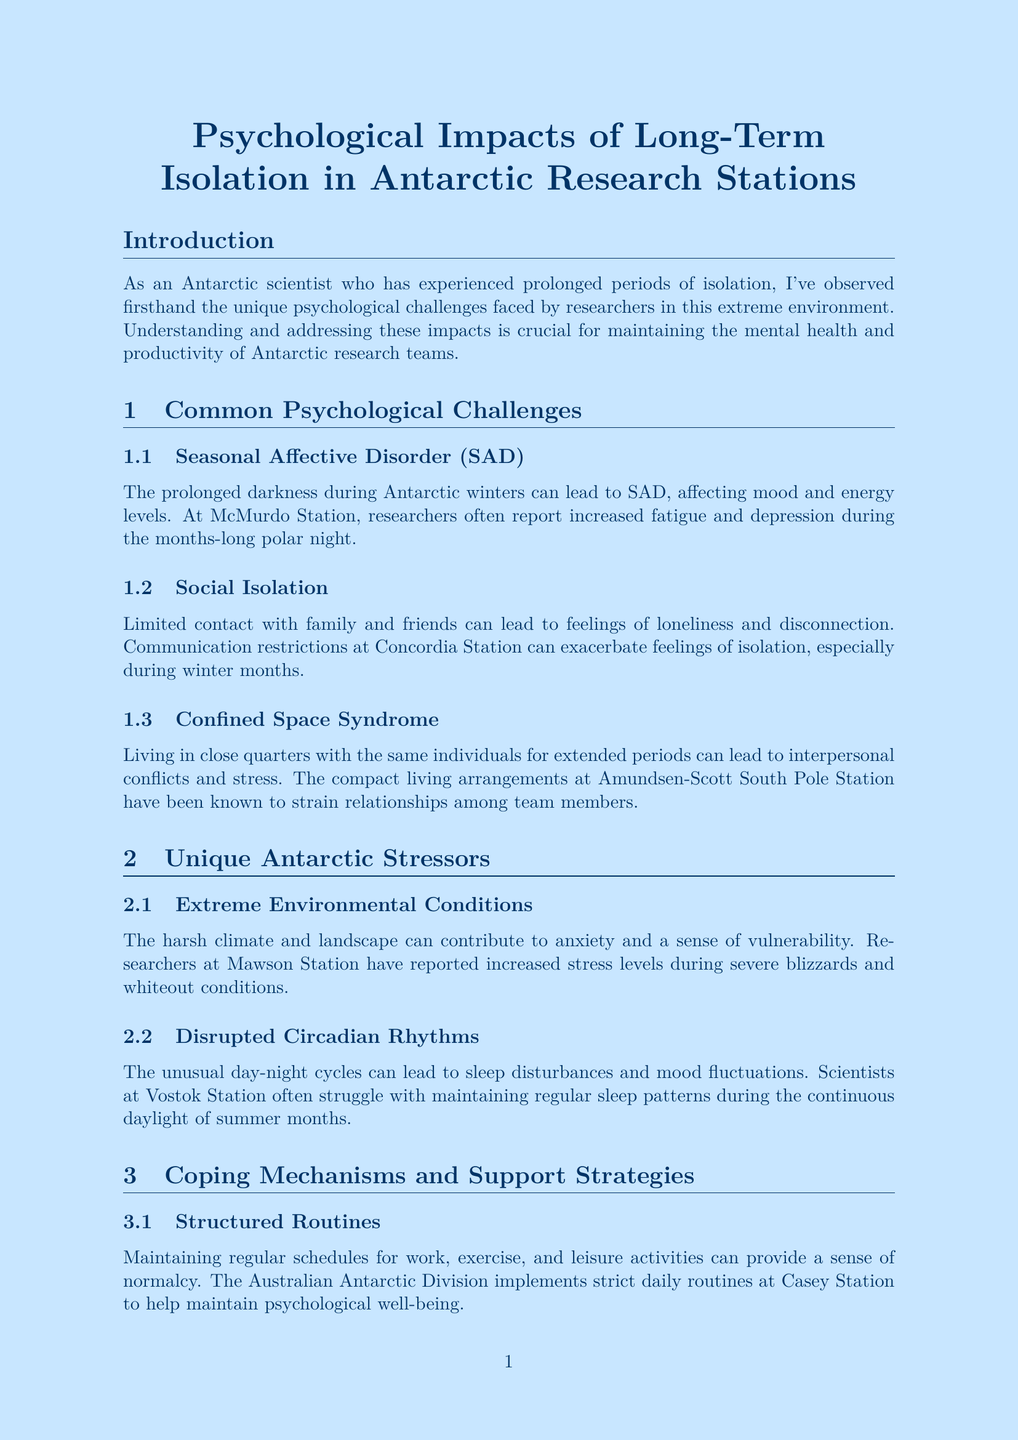What is the title of the report? The title clearly states the focus of the report, which is about the psychological impacts experienced by researchers in isolation.
Answer: Psychological Impacts of Long-Term Isolation in Antarctic Research Stations What is one example of Seasonal Affective Disorder effects at McMurdo Station? The report provides a specific example illustrating the psychological challenge of SAD as reported by researchers during polar night.
Answer: Increased fatigue and depression What psychological challenge is associated with limited contact with family and friends? This inquiry pertains to the specific psychological challenge highlighted in the document related to isolation.
Answer: Social Isolation What recommendation is made for on-site mental health support? The document outlines specific recommendations to address mental health issues, including the presence of a professional.
Answer: On-site Mental Health Professional How many main sections are there in the document? The structure of the document includes multiple sections, and counting them provides an overview of its organization.
Answer: Three What coping mechanism involves structured daily routines? The report discusses strategies to support mental health, with a focus on maintaining regular schedules.
Answer: Structured Routines What unique stressor is linked to the harsh Antarctic climate? This question requires recognition of specific stressors highlighted in the document relating to environmental conditions.
Answer: Extreme Environmental Conditions Which research station has implemented mindfulness workshops? This question probes a specific example provided in the report regarding coping strategies utilized in different stations.
Answer: Rothera Research Station 